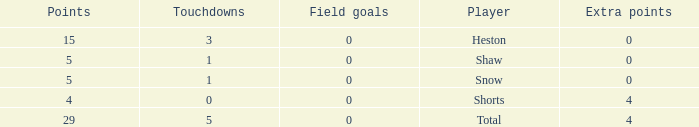What is the sum of all the touchdowns when the player had more than 0 extra points and less than 0 field goals? None. 